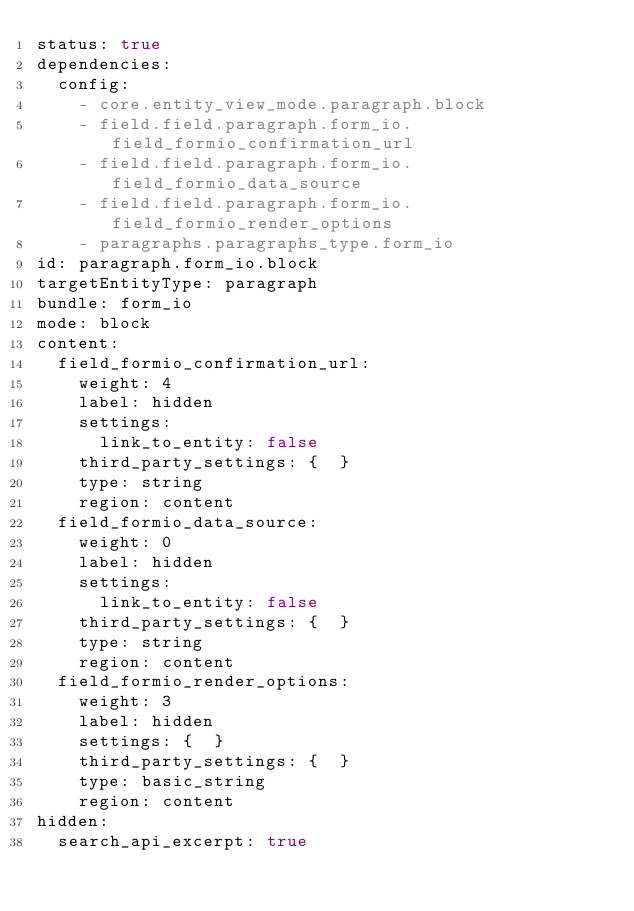<code> <loc_0><loc_0><loc_500><loc_500><_YAML_>status: true
dependencies:
  config:
    - core.entity_view_mode.paragraph.block
    - field.field.paragraph.form_io.field_formio_confirmation_url
    - field.field.paragraph.form_io.field_formio_data_source
    - field.field.paragraph.form_io.field_formio_render_options
    - paragraphs.paragraphs_type.form_io
id: paragraph.form_io.block
targetEntityType: paragraph
bundle: form_io
mode: block
content:
  field_formio_confirmation_url:
    weight: 4
    label: hidden
    settings:
      link_to_entity: false
    third_party_settings: {  }
    type: string
    region: content
  field_formio_data_source:
    weight: 0
    label: hidden
    settings:
      link_to_entity: false
    third_party_settings: {  }
    type: string
    region: content
  field_formio_render_options:
    weight: 3
    label: hidden
    settings: {  }
    third_party_settings: {  }
    type: basic_string
    region: content
hidden:
  search_api_excerpt: true
</code> 